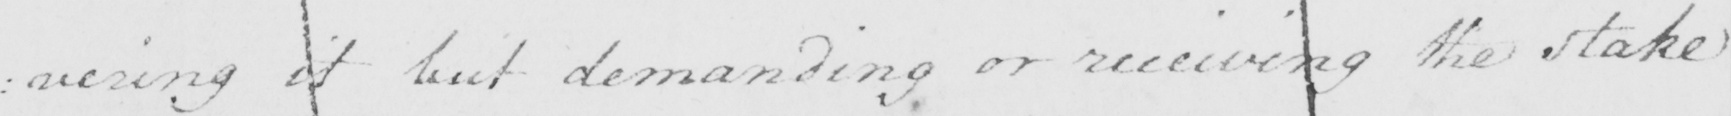What is written in this line of handwriting? : vering it but demanding or receiving the stake 